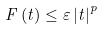<formula> <loc_0><loc_0><loc_500><loc_500>F \left ( t \right ) \leq \varepsilon \left | t \right | ^ { p }</formula> 